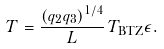Convert formula to latex. <formula><loc_0><loc_0><loc_500><loc_500>T = \frac { { ( q _ { 2 } q _ { 3 } ) ^ { 1 / 4 } } } { L } \, T _ { \text {BTZ} } \epsilon .</formula> 